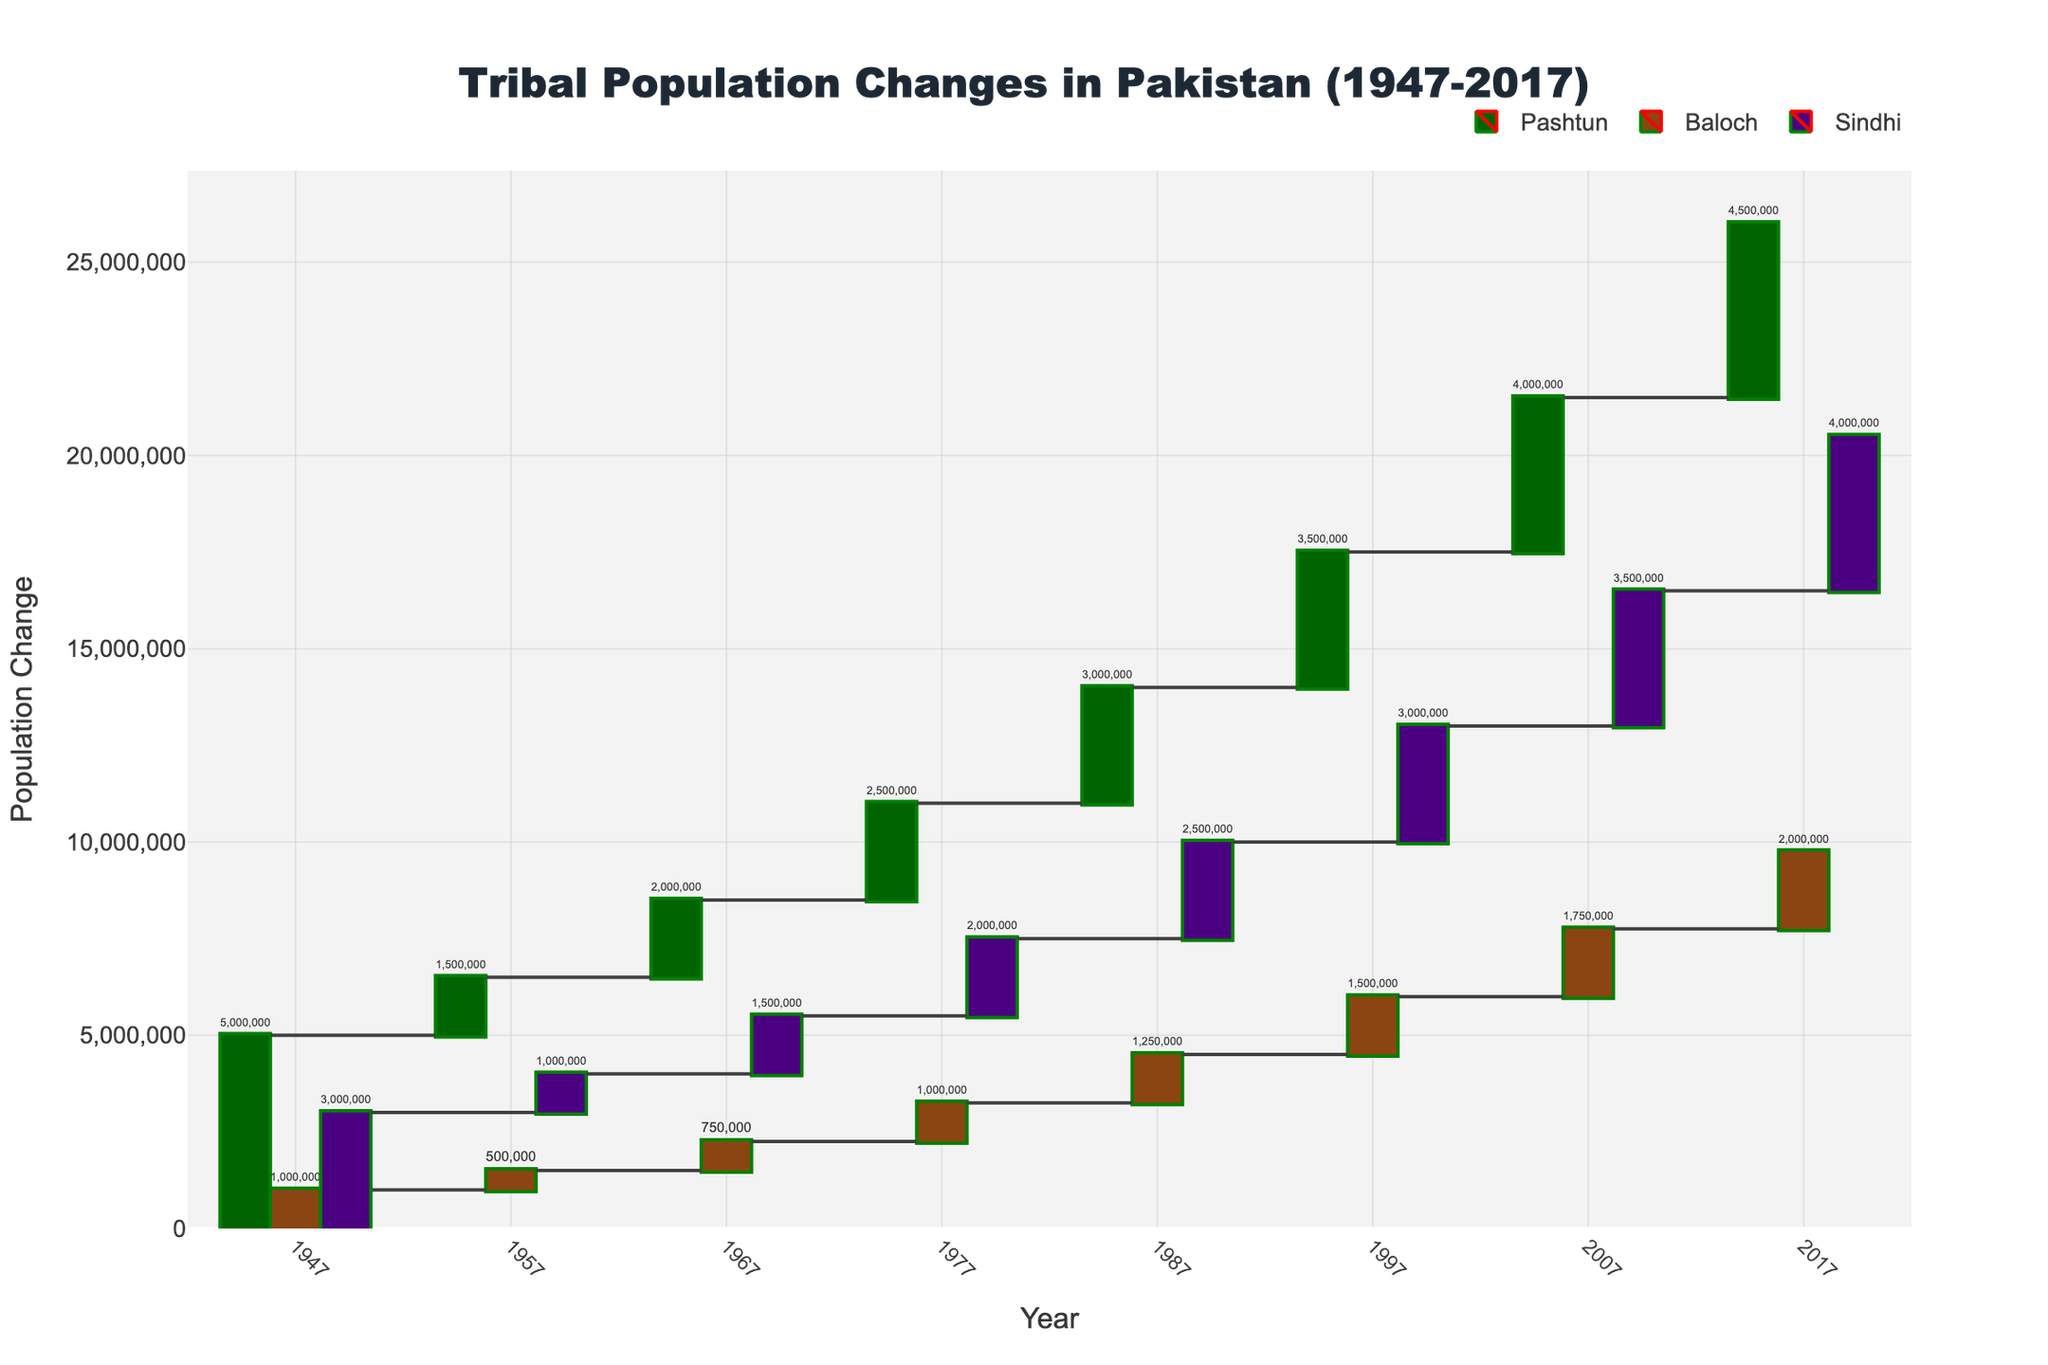what is the title of the chart? The title of the chart is located at the top, formatted in a larger and more prominent font. The title reads "Tribal Population Changes in Pakistan (1947-2017)".
Answer: Tribal Population Changes in Pakistan (1947-2017) Which tribe experienced the most significant population increase between 1947 and 2017? To find the tribe with the most significant population increase, check the total population change for each tribe from 1947 to 2017. The Pashtun tribe shows the largest increase from 5,000,000 in 1947 to 4,500,000 in 2017.
Answer: Pashtun How did the Sindhi population change from 1957 to 1967? Examine the population changes for the Sindhi tribe between the selected years. The Sindhi population increased by 500,000 from 1957 (1,000,000) to 1967 (1,500,000).
Answer: Increased by 500,000 What is the total population change of the Baloch tribe over the 70 years? Calculate by summing up periodic changes from 1947 to 2017 for the Baloch tribe: 500,000 + 250,000 + 250,000 + 250,000 + 250,000 + 250,000 = 1,000,000.
Answer: 1,000,000 Which decade saw the largest population growth for the Pashtun tribe? Analyze the decade-wise changes, and the largest increase for Pashtun people was noted between 1947 and 1957 with 1,500,000.
Answer: 1947-1957 Did any tribe experience negative population change in any decade? Check for any negative movements in the population values across the periods for each tribe. None of the tribes experienced a decline or negative change in population in any decade.
Answer: No Compare the population change of Baloch and Sindhi tribes during 1977-1987. Identify the population change for each tribe in the decade mentioned: Baloch had a 250,000 increase and Sindhi had a 500,000 increase.
Answer: Sindhi had a larger increase Which tribe had the smallest population change in 2017? Look at the Population Change values for each tribe in 2017. The Baloch tribe had the smallest population increase with 2,000,000 in total since 1947.
Answer: Baloch What is the average population change per decade for the Sindhi tribe? Calculate by summing all changes and then dividing by the number of decades: (1,000,000 + 500,000 + 500,000 + 500,000 + 500,000 + 500,000 + 500,000) / 7 = 500,000.
Answer: 500,000 Compare the cumulative population changes of Pashtun and Sindhi tribes over the entire period. Sum the decade changes for both tribes: Pashtun's total is 24,500,000 and Sindhi’s total is 14,000,000. Pashtun had a larger cumulative change.
Answer: Pashtun had a larger change 